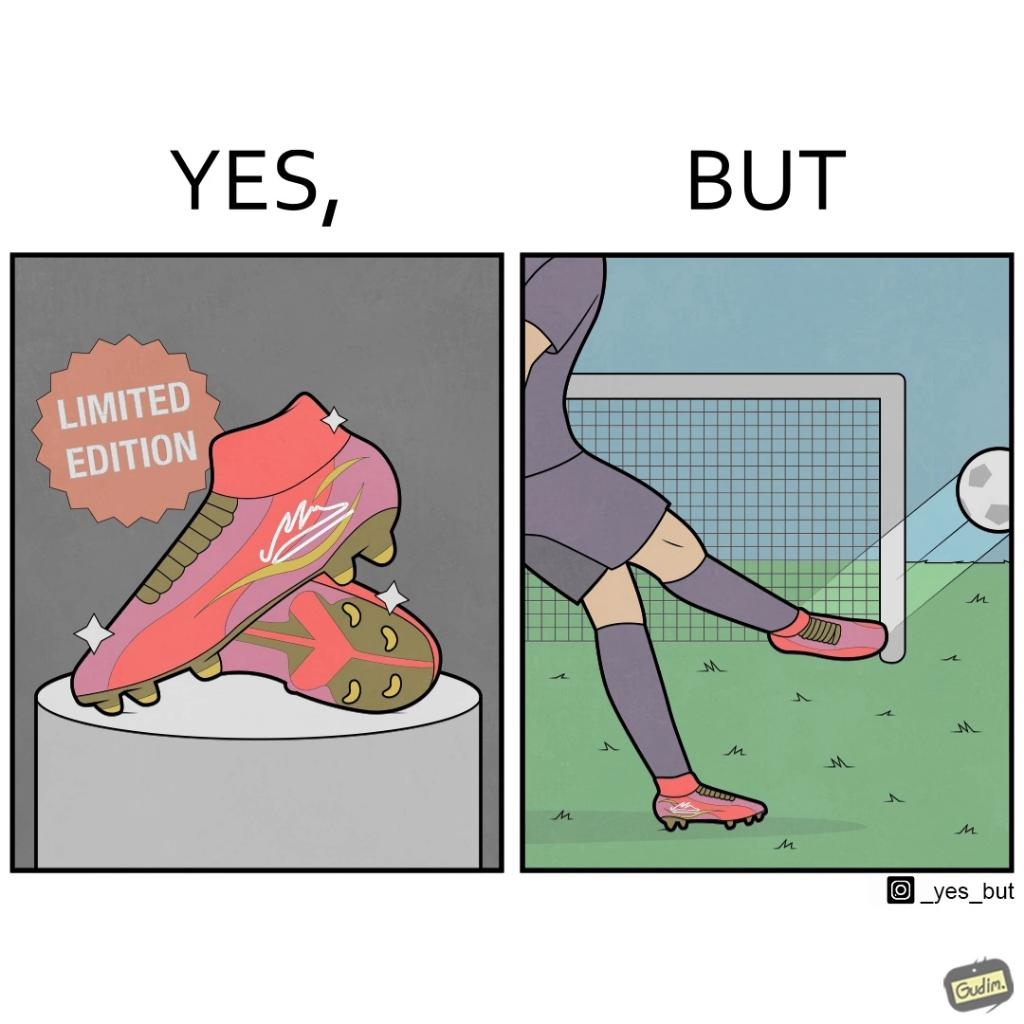Explain why this image is satirical. The images are funny since they show how wearing expensive football boots does not make the user a better footballer. The footballer is still just as bad and it is a waste for him to buy such expensive boots 